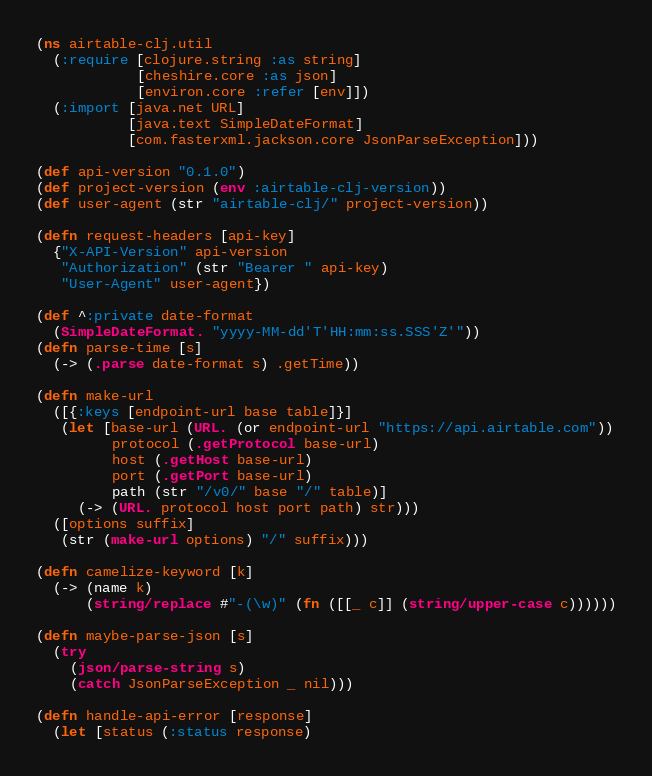<code> <loc_0><loc_0><loc_500><loc_500><_Clojure_>(ns airtable-clj.util
  (:require [clojure.string :as string]
            [cheshire.core :as json]
            [environ.core :refer [env]])
  (:import [java.net URL]
           [java.text SimpleDateFormat]
           [com.fasterxml.jackson.core JsonParseException]))

(def api-version "0.1.0")
(def project-version (env :airtable-clj-version))
(def user-agent (str "airtable-clj/" project-version))

(defn request-headers [api-key]
  {"X-API-Version" api-version
   "Authorization" (str "Bearer " api-key)
   "User-Agent" user-agent})

(def ^:private date-format
  (SimpleDateFormat. "yyyy-MM-dd'T'HH:mm:ss.SSS'Z'"))
(defn parse-time [s]
  (-> (.parse date-format s) .getTime))

(defn make-url
  ([{:keys [endpoint-url base table]}]
   (let [base-url (URL. (or endpoint-url "https://api.airtable.com"))
         protocol (.getProtocol base-url)
         host (.getHost base-url)
         port (.getPort base-url)
         path (str "/v0/" base "/" table)]
     (-> (URL. protocol host port path) str)))
  ([options suffix]
   (str (make-url options) "/" suffix)))

(defn camelize-keyword [k]
  (-> (name k)
      (string/replace #"-(\w)" (fn ([[_ c]] (string/upper-case c))))))

(defn maybe-parse-json [s]
  (try
    (json/parse-string s)
    (catch JsonParseException _ nil)))

(defn handle-api-error [response]
  (let [status (:status response)</code> 